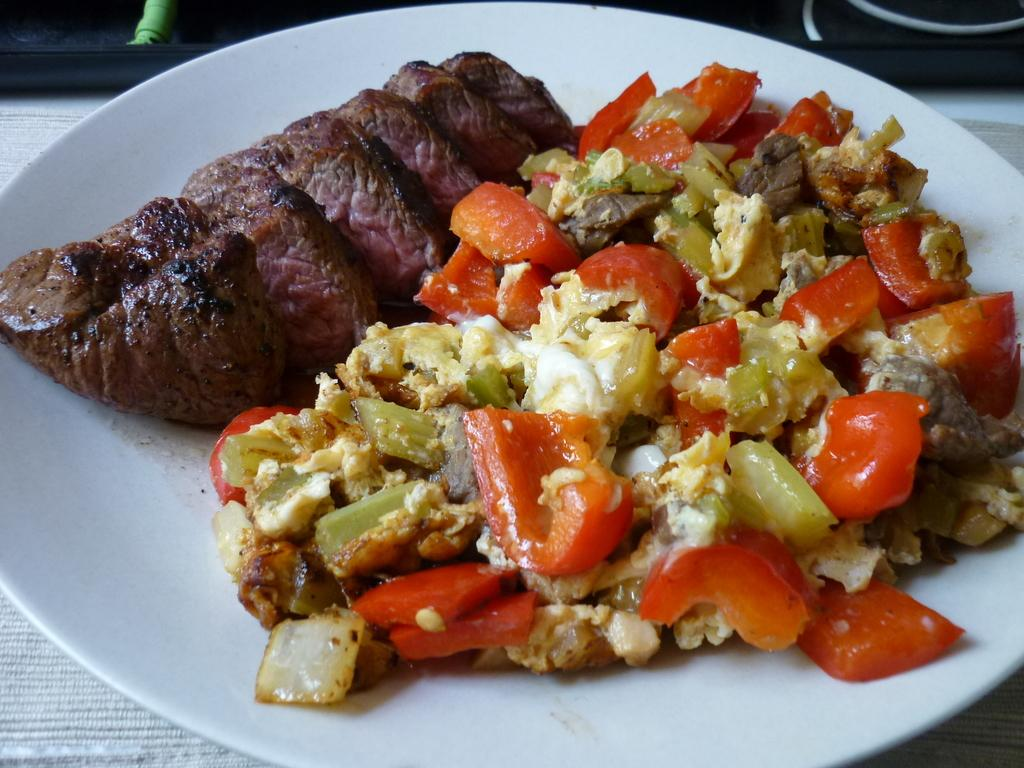What is present on the plate in the image? There are food items on the plate in the image. Can you describe the food items on the plate? Unfortunately, the specific food items cannot be determined from the provided facts. How does the plate use its tongue to taste the food in the image? Plates do not have tongues, as they are inanimate objects. The question is based on an absurd topic and cannot be answered definitively be answered in the context of the image. 